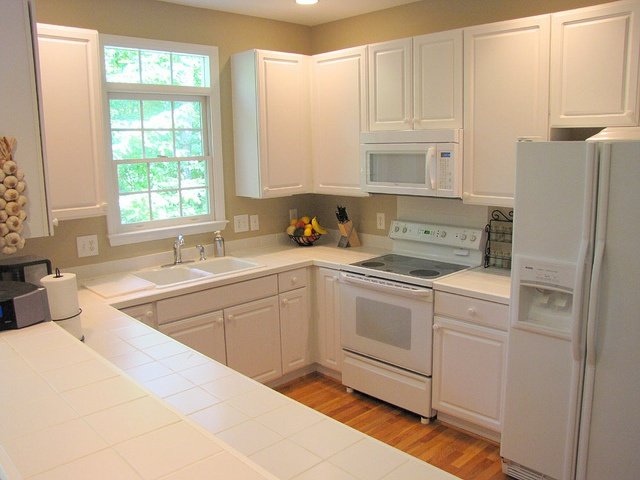Describe the objects in this image and their specific colors. I can see refrigerator in gray and darkgray tones, oven in gray, tan, and darkgray tones, microwave in gray, darkgray, and tan tones, sink in gray, tan, and lightgray tones, and sink in gray, tan, and lightgray tones in this image. 